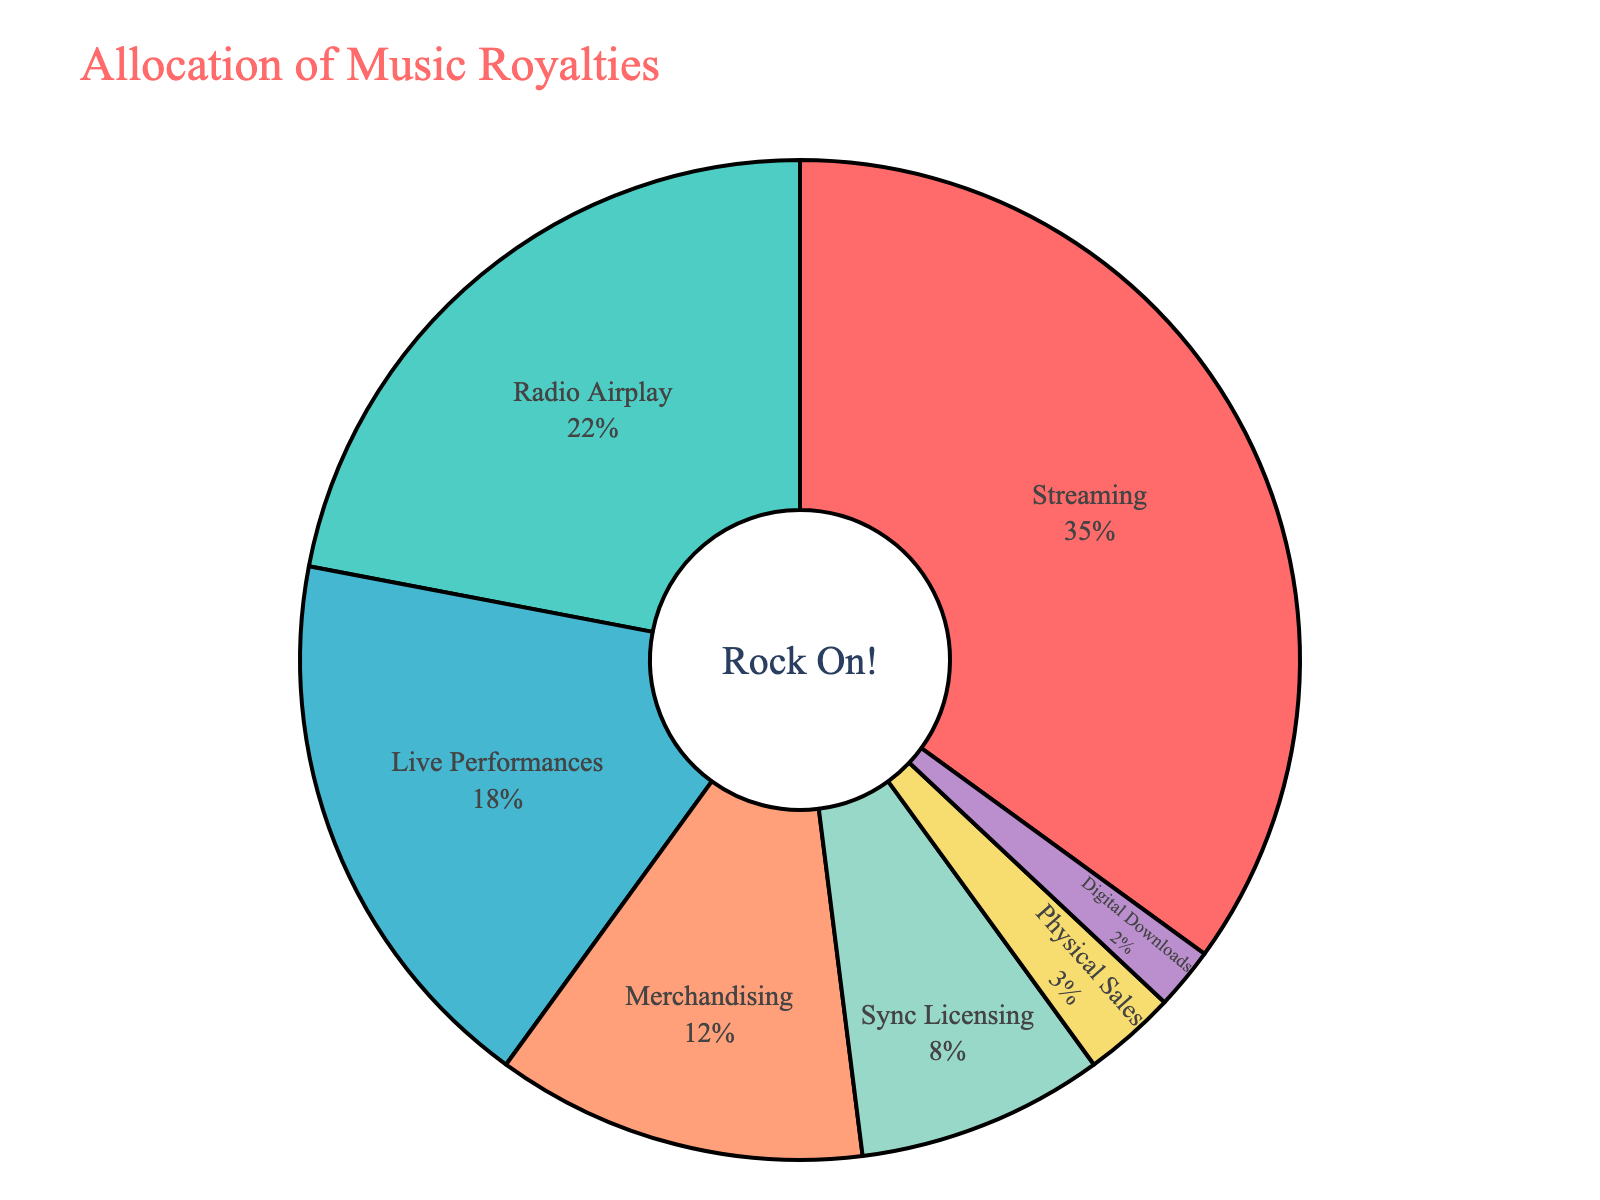What percentage of music royalties comes from live performances? To answer this, look for the segment in the pie chart labeled "Live Performances". The pie chart shows that "Live Performances" account for 18% of the music royalties.
Answer: 18% Compare the revenue from streaming and radio airplay. Which one contributes more to music royalties? The pie chart shows "Streaming" contributes 35% and "Radio Airplay" contributes 22%. To compare, 35% is greater than 22%, so streaming contributes more.
Answer: Streaming What is the combined percentage of royalties from merchandising and sync licensing? Look at the segments labeled "Merchandising" and "Sync Licensing". "Merchandising" is 12% and "Sync Licensing" is 8%. Add these percentages: 12% + 8% = 20%.
Answer: 20% How much more percentage of music royalties does digital downloads contribute compared to physical sales? Locate the "Digital Downloads" segment at 2% and "Physical Sales" segment at 3%. Calculate the difference: 3% - 2% = 1%. Since physical sales are higher, digital downloads contribute 1% less.
Answer: 1% less What percentage of the total royalties do streaming and physical sales contribute together? Identify the percentages for "Streaming" (35%) and "Physical Sales" (3%). Sum these percentages: 35% + 3% = 38%.
Answer: 38% Identify the revenue stream with the lowest allocation of music royalties and state its percentage. The smallest segment in the pie chart represents "Digital Downloads" with a percentage of 2%.
Answer: Digital Downloads, 2% Compare the proportion of royalties from live performances to merchandising visually. Which segment is larger and by how much? The pie chart shows "Live Performances" (18%) is larger than "Merchandising" (12%). Calculate the difference: 18% - 12% = 6%. So, "Live Performances" has 6% more.
Answer: Live Performances, 6% Which revenue stream represents the second largest segment in the pie chart? The largest segment is "Streaming" (35%). The second largest segment is "Radio Airplay" (22%).
Answer: Radio Airplay If the percentages for physical sales and digital downloads were combined, would they surpass the percentage from sync licensing? "Physical Sales" is 3% and "Digital Downloads" is 2%. Combined, they add up to 3% + 2% = 5%. This is less than "Sync Licensing" which is 8%.
Answer: No What percentage of royalties comes from sources other than streaming, radio airplay, and live performances? Sum the percentages of streaming, radio airplay, and live performances: 35% + 22% + 18% = 75%. Subtract this from 100% to find the remainder: 100% - 75% = 25%.
Answer: 25% 